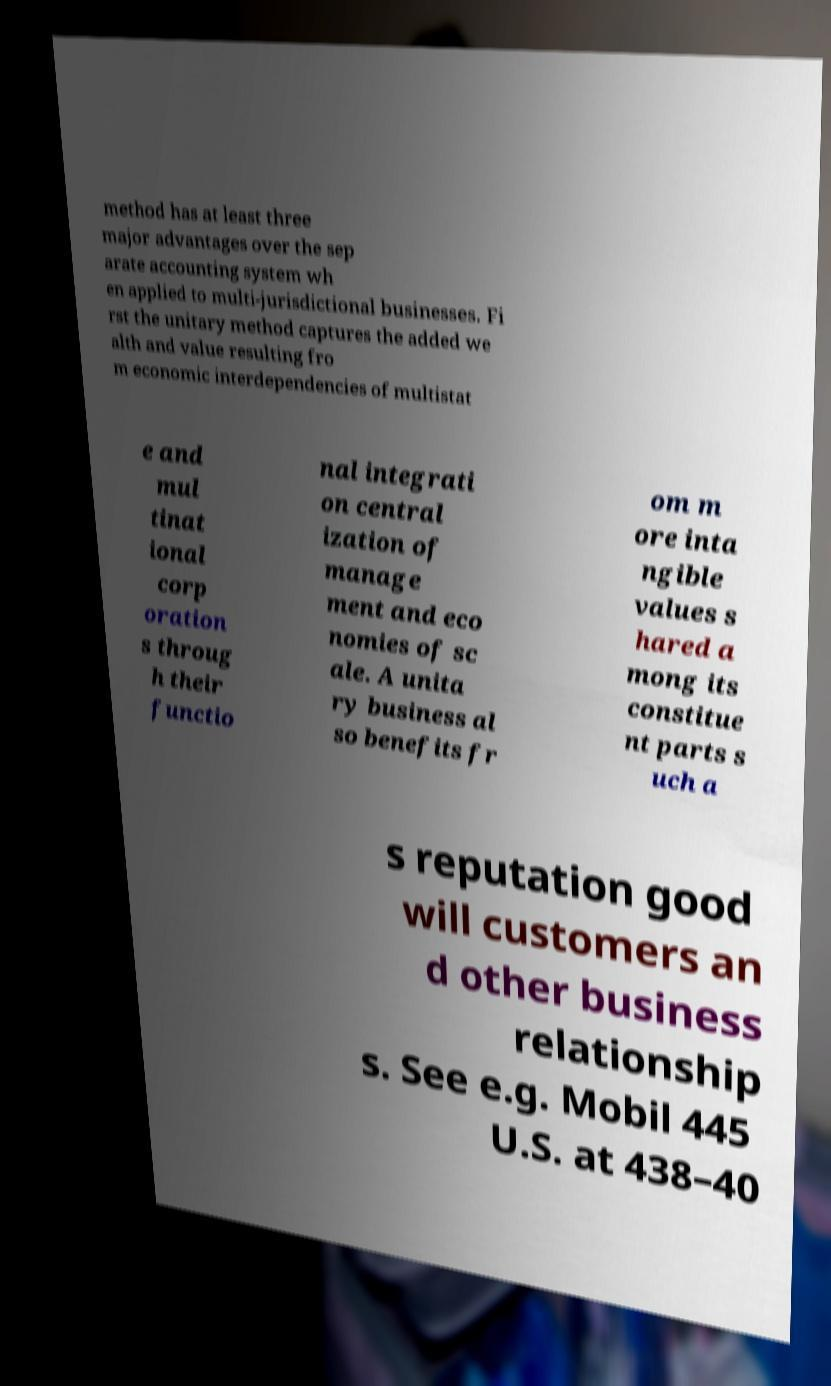Please identify and transcribe the text found in this image. method has at least three major advantages over the sep arate accounting system wh en applied to multi-jurisdictional businesses. Fi rst the unitary method captures the added we alth and value resulting fro m economic interdependencies of multistat e and mul tinat ional corp oration s throug h their functio nal integrati on central ization of manage ment and eco nomies of sc ale. A unita ry business al so benefits fr om m ore inta ngible values s hared a mong its constitue nt parts s uch a s reputation good will customers an d other business relationship s. See e.g. Mobil 445 U.S. at 438–40 